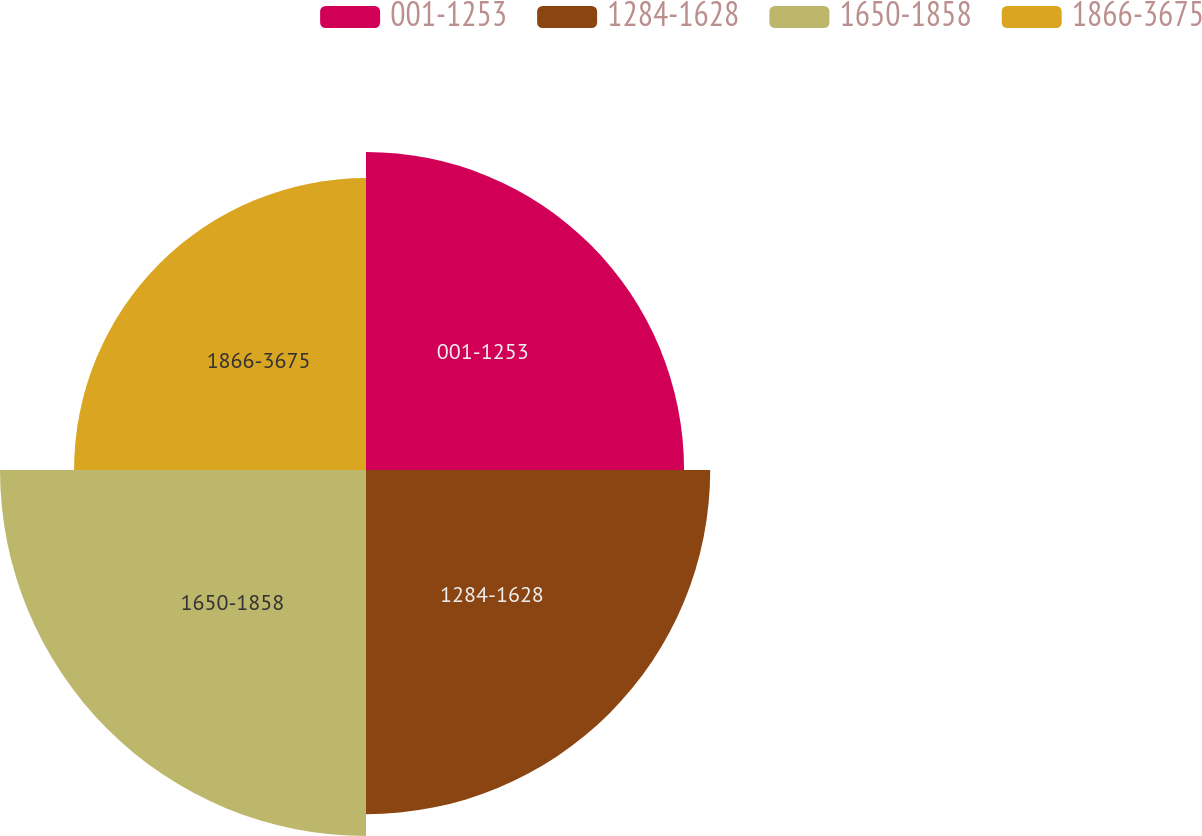Convert chart. <chart><loc_0><loc_0><loc_500><loc_500><pie_chart><fcel>001-1253<fcel>1284-1628<fcel>1650-1858<fcel>1866-3675<nl><fcel>24.09%<fcel>26.07%<fcel>27.72%<fcel>22.11%<nl></chart> 